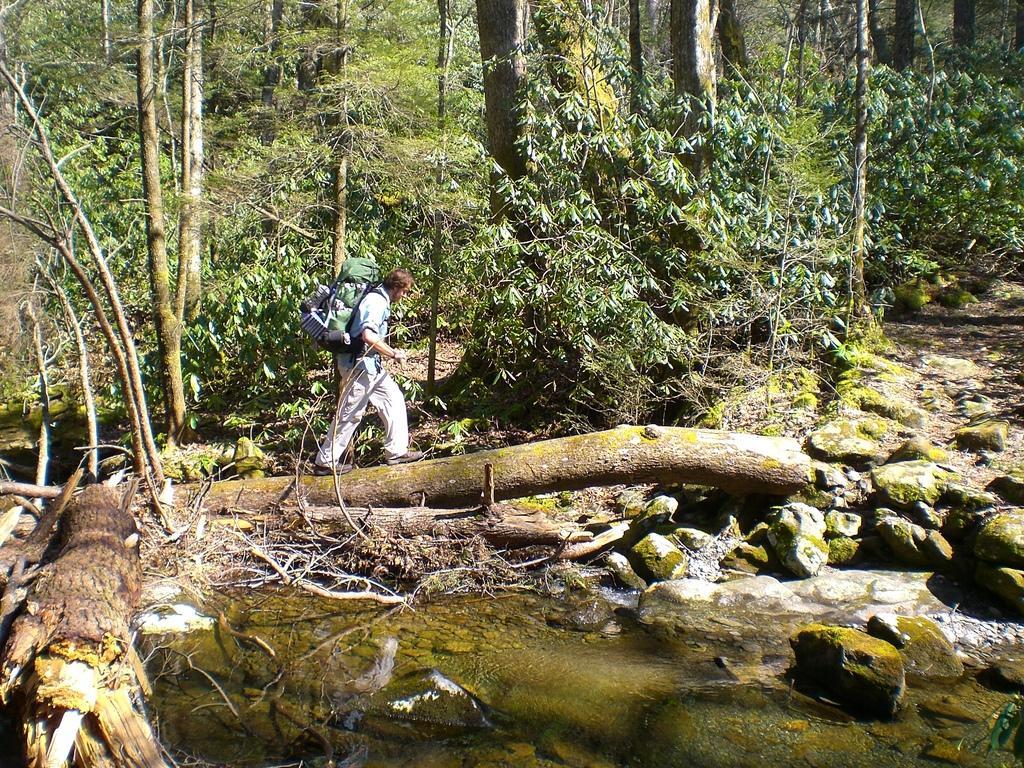Can you describe this image briefly? In this image we can see many trees. There is a water in the image. There are few rocks in the image. A person is walking on the wooden log and carrying some objects in the image. 